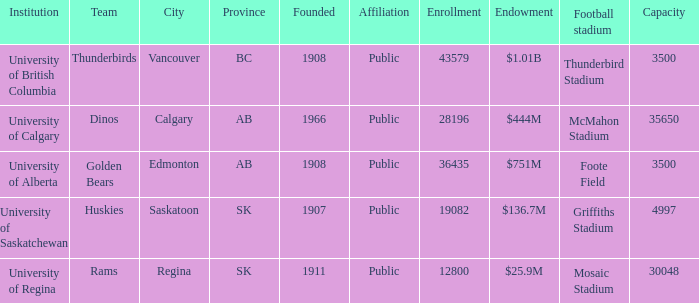Which entity holds a $2 University of Regina. 